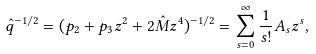Convert formula to latex. <formula><loc_0><loc_0><loc_500><loc_500>\hat { q } ^ { - 1 / 2 } = ( p _ { 2 } + p _ { 3 } z ^ { 2 } + 2 \hat { M } z ^ { 4 } ) ^ { - 1 / 2 } = \sum _ { s = 0 } ^ { \infty } \frac { 1 } { s ! } A _ { s } z ^ { s } ,</formula> 